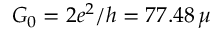Convert formula to latex. <formula><loc_0><loc_0><loc_500><loc_500>G _ { 0 } = 2 e ^ { 2 } / h = 7 7 . 4 8 \, \mu</formula> 